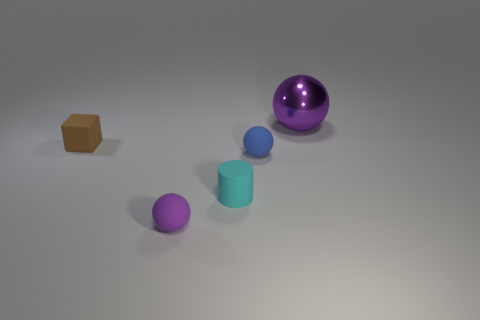Are there any spheres of the same size as the blue thing?
Ensure brevity in your answer.  Yes. What number of green matte cubes are there?
Your answer should be compact. 0. How many large things are either rubber balls or purple rubber things?
Ensure brevity in your answer.  0. There is a tiny matte ball behind the purple ball that is to the left of the metal object right of the small purple ball; what color is it?
Your response must be concise. Blue. What number of other things are there of the same color as the matte cylinder?
Offer a terse response. 0. How many matte objects are big purple balls or big cyan cylinders?
Ensure brevity in your answer.  0. Do the matte ball to the left of the small blue rubber thing and the object that is behind the brown object have the same color?
Your answer should be compact. Yes. Is there any other thing that has the same material as the large sphere?
Make the answer very short. No. The blue matte thing that is the same shape as the tiny purple matte thing is what size?
Your answer should be very brief. Small. Is the number of tiny matte spheres left of the large purple metallic sphere greater than the number of tiny blue matte balls?
Make the answer very short. Yes. 